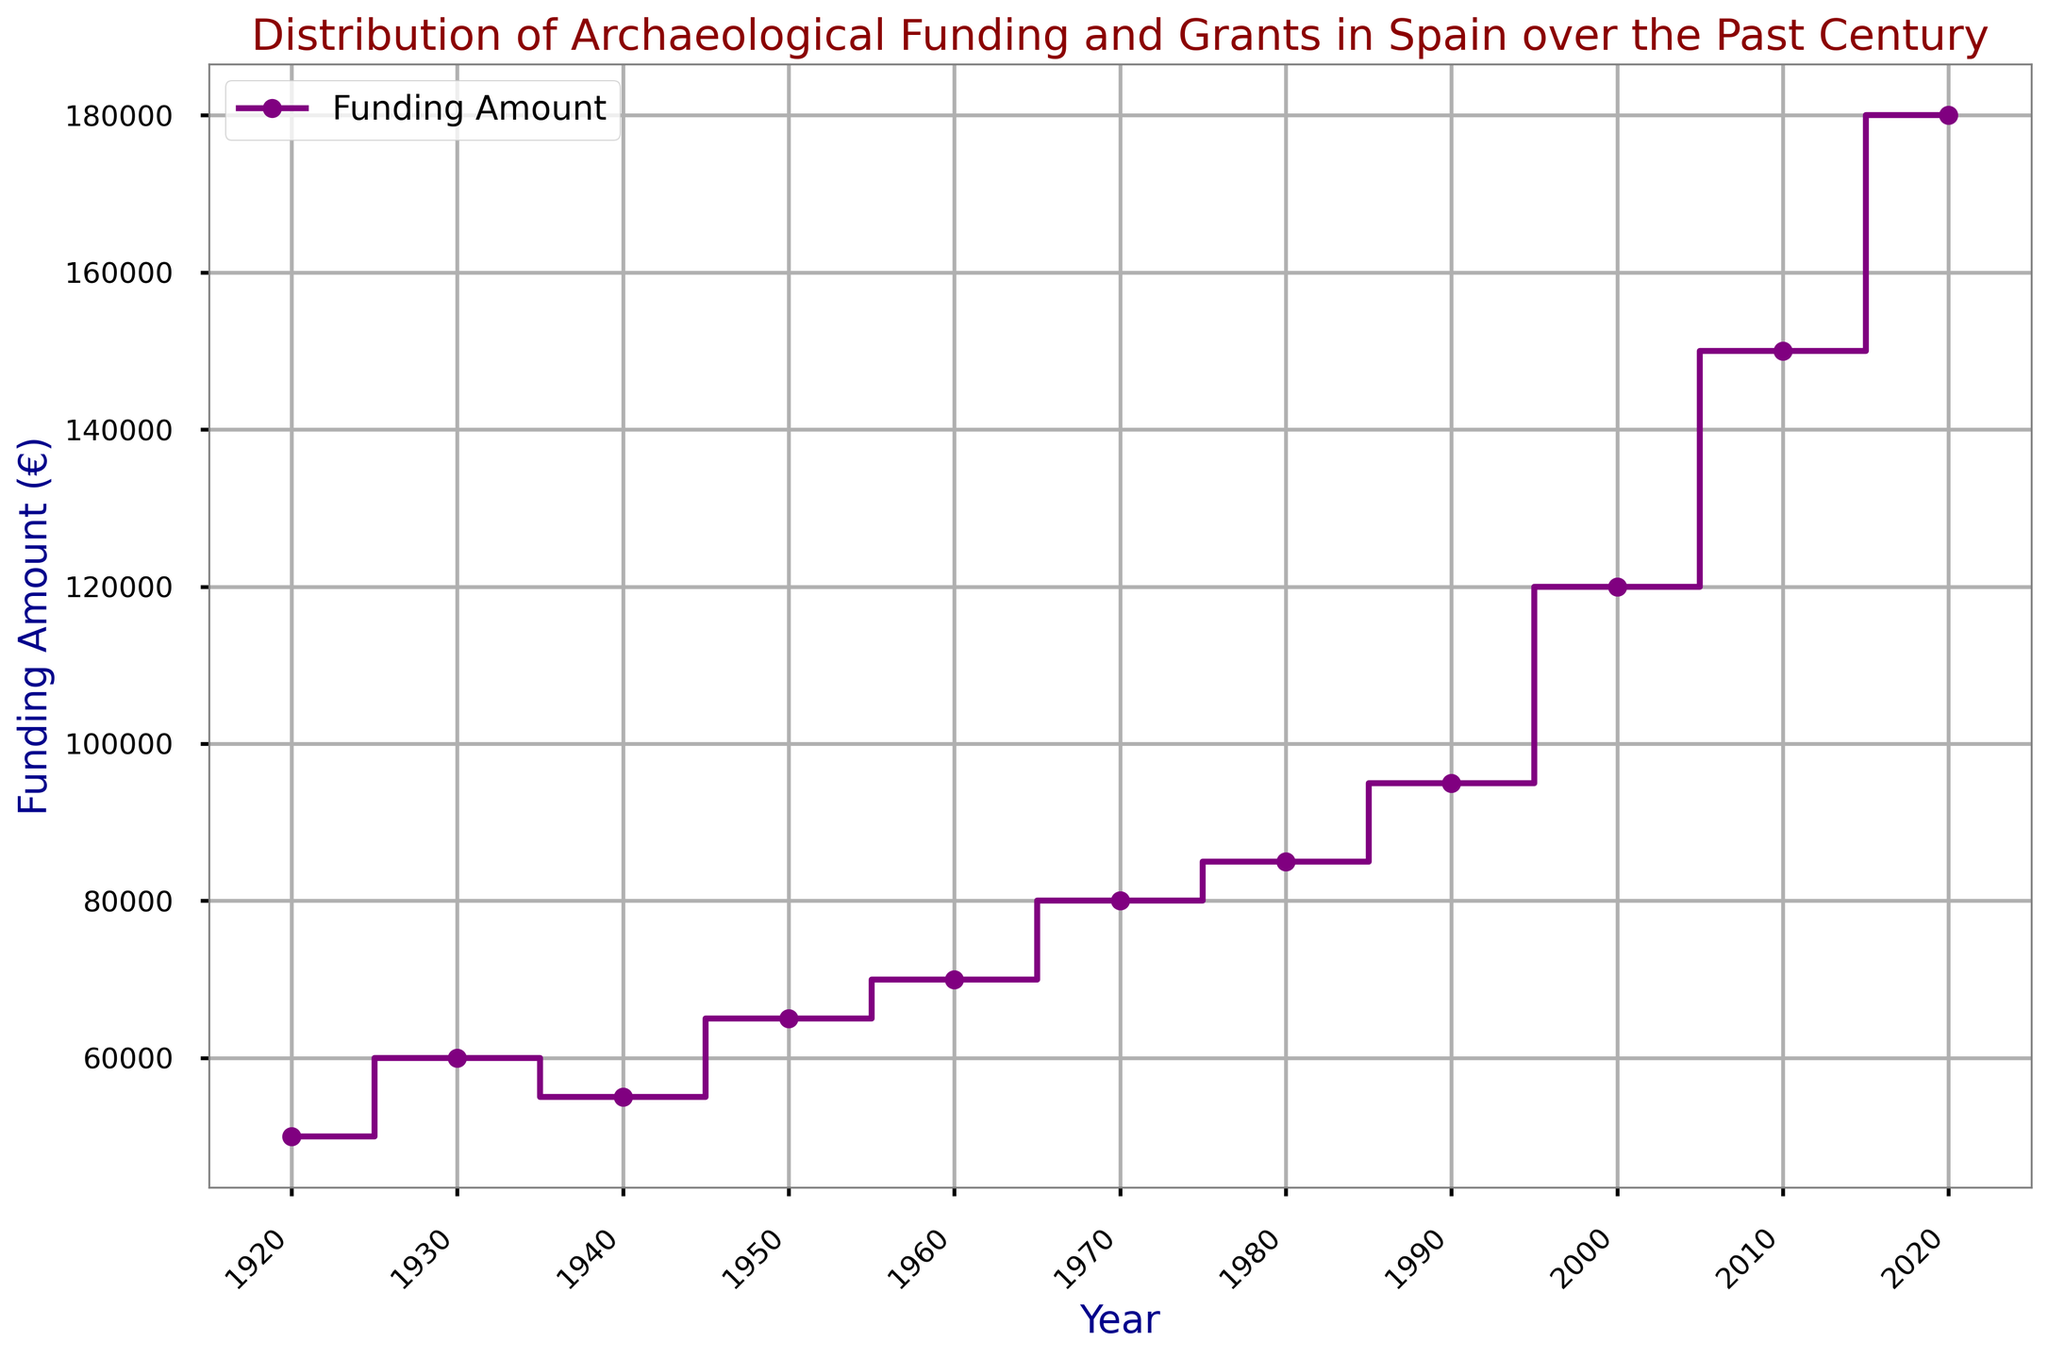How much did the funding amount increase between 1920 and 2020? To determine the funding increase, subtract the funding amount in 1920 (€50,000) from the funding amount in 2020 (€180,000). The increase is €180,000 - €50,000 = €130,000.
Answer: €130,000 In which decade did the funding amount first reach €100,000? To answer this, locate the decade on the plot where the funding amount first surpasses €100,000. From the plot, this occurs around the year 2000.
Answer: 2000s Which decade saw the highest absolute increase in funding amount? Calculate the difference in funding amounts between each adjacent decade. The largest increase can be seen between 1990 (€95,000) and 2000 (€120,000), which is €120,000 - €95,000 = €25,000.
Answer: 1990s How much was the funding amount in 1940 compared to 1960? Compare the funding amounts for the years 1940 (€55,000) and 1960 (€70,000).
Answer: €55,000 in 1940, €70,000 in 1960 What is the average funding amount from 1920 to 2020? To find the average, add all the funding amounts and then divide by the number of data points (11 years). The total funding amount is €50,000 + €60,000 + €55,000 + €65,000 + €70,000 + €80,000 + €85,000 + €95,000 + €120,000 + €150,000 + €180,000 = €1,010,000. The average is €1,010,000 / 11 = €91,818.18.
Answer: €91,818.18 What is the funding trajectory between 1980 and 1990? Observe the plot to see the change in funding. The funding increased from €85,000 in 1980 to €95,000 in 1990.
Answer: Increased By what percentage did the funding amount increase from 2000 to 2010? Calculate the percentage increase using the formula \[( (New Value - Old Value) / Old Value ) × 100 \]. Here, the old value is €120,000 and the new value is €150,000. Therefore, the calculation is \(( (€150,000 - €120,000) / €120,000 ) × 100 = 25\% \).
Answer: 25% What distinct visual elements help to easily identify the funding amount for each year? The plot uses a purple step line with markers at each year's data point, making it easy to read the funding amounts directly from the plot.
Answer: Purple step line with markers At what point does the funding plot display the steepest increase? The steepest increase can be identified visually from the plot. This occurs between the years 2000 (€120,000) and 2010 (€150,000).
Answer: Between 2000 and 2010 